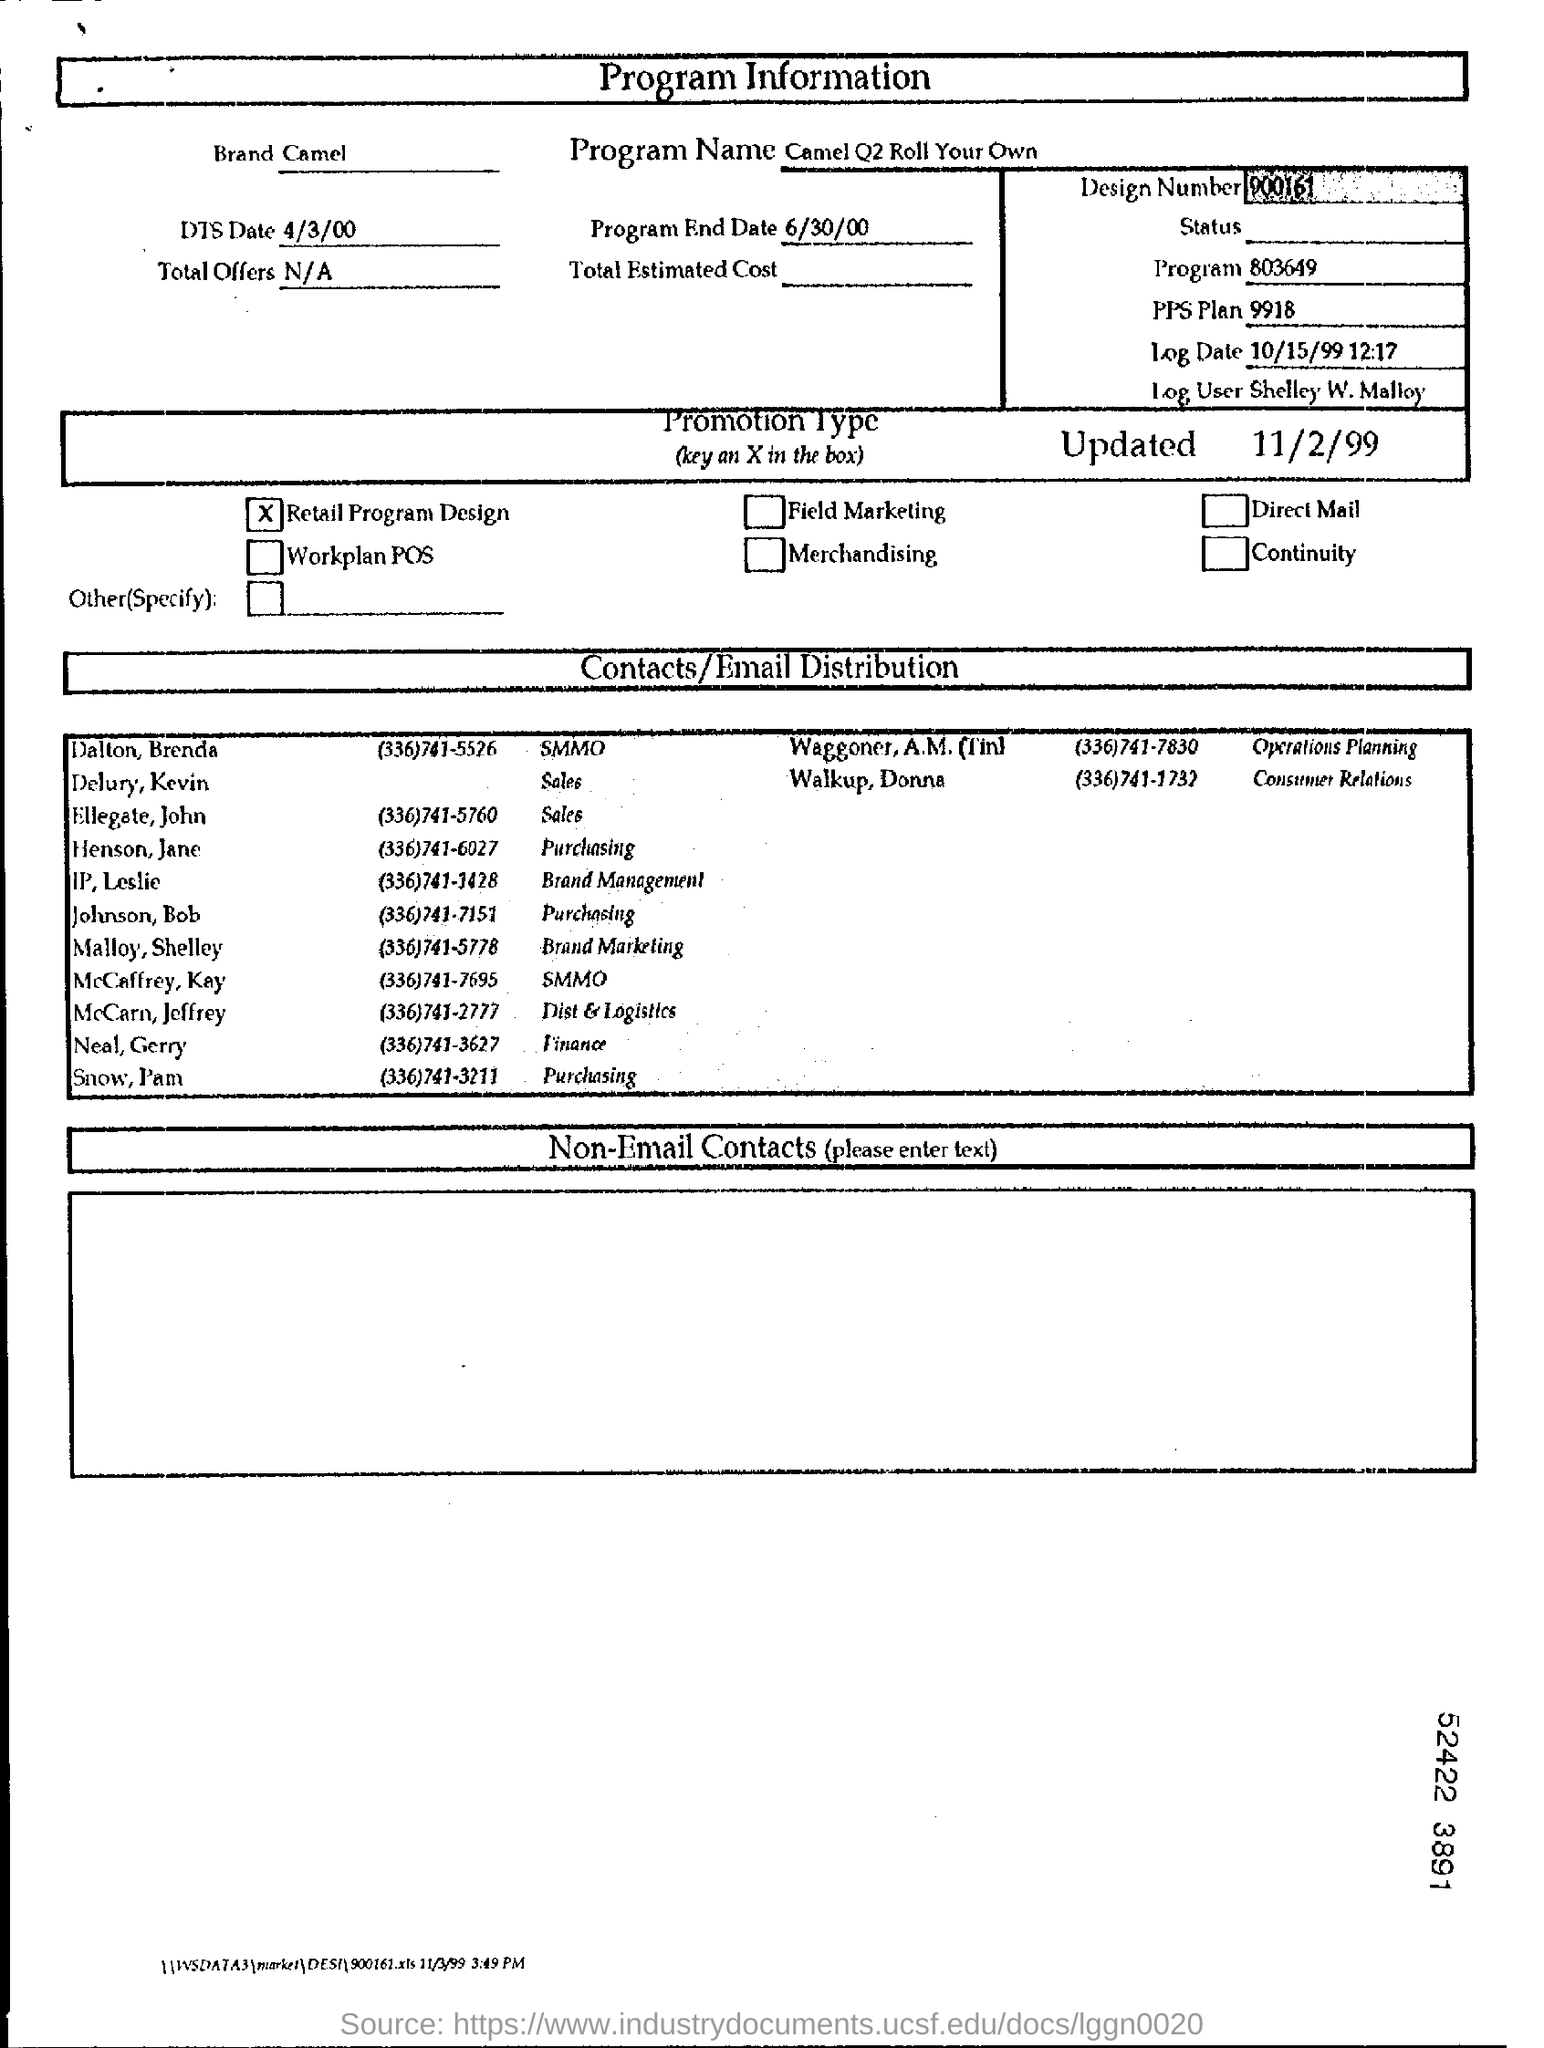What is the page about?
Ensure brevity in your answer.  Program information. What is the program end date?
Your answer should be very brief. 6/30/00. What is the total offer on the page?
Offer a terse response. N/A. Who is log user on this page?
Give a very brief answer. Shelley W. Malloy. 